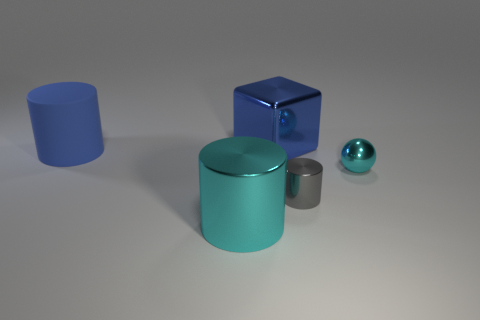Subtract all metal cylinders. How many cylinders are left? 1 Add 4 gray cylinders. How many objects exist? 9 Subtract 3 cylinders. How many cylinders are left? 0 Subtract all blocks. How many objects are left? 4 Subtract all purple balls. How many purple cubes are left? 0 Add 5 big things. How many big things are left? 8 Add 3 big shiny cubes. How many big shiny cubes exist? 4 Subtract all gray cylinders. How many cylinders are left? 2 Subtract 0 gray spheres. How many objects are left? 5 Subtract all brown cubes. Subtract all gray spheres. How many cubes are left? 1 